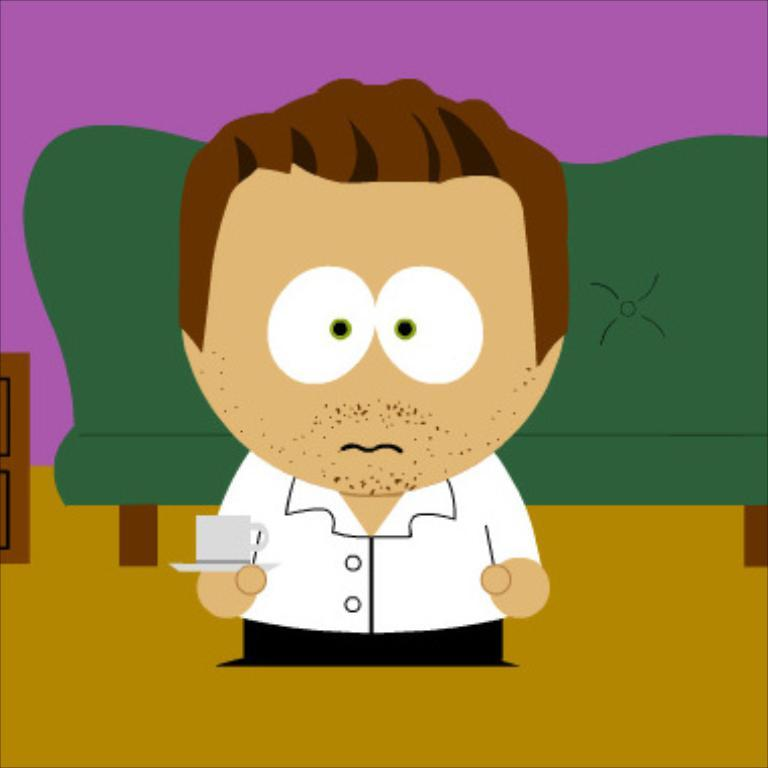What is depicted in the image as the main subject? There is a cartoon of a person in the image. What is the person holding in the image? The person is holding a cup in the image. What type of furniture can be seen in the image? There is a sofa in the image. What else can be seen in the image besides the person and the sofa? There are other objects in the image. What is visible in the background of the image? There is a wall in the background of the image. How many pizzas are being measured on the canvas in the image? There is no canvas or pizzas present in the image. 